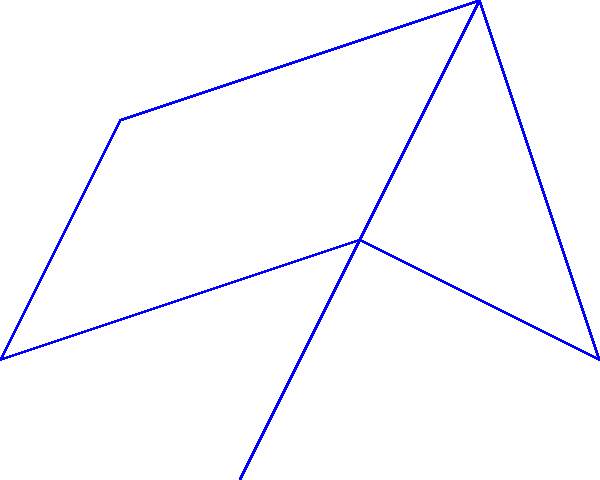As the CEO of your startup, you're planning to connect multiple office locations. The graph represents potential connections between offices, with vertices representing locations and edge weights representing connection costs (in millions). What is the total cost of the optimal spanning tree to connect all offices while minimizing expenses? To find the optimal spanning tree (minimum spanning tree) and its total cost, we'll use Kruskal's algorithm:

1. Sort edges by weight in ascending order:
   $(v_3, v_5)$: 2
   $(v_2, v_3)$: 3
   $(v_1, v_2)$: 4
   $(v_1, v_3)$: 5
   $(v_2, v_4)$: 6
   $(v_3, v_6)$: 7
   $(v_4, v_6)$: 8

2. Add edges to the tree, skipping those that create cycles:
   - Add $(v_3, v_5)$: cost = 2
   - Add $(v_2, v_3)$: cost = 2 + 3 = 5
   - Add $(v_1, v_2)$: cost = 5 + 4 = 9
   - Skip $(v_1, v_3)$ (creates cycle)
   - Add $(v_2, v_4)$: cost = 9 + 6 = 15
   - Add $(v_3, v_6)$: cost = 15 + 7 = 22

3. All vertices are now connected, and we have the minimum spanning tree.

The total cost of the optimal spanning tree is $22 million.
Answer: $22 million 